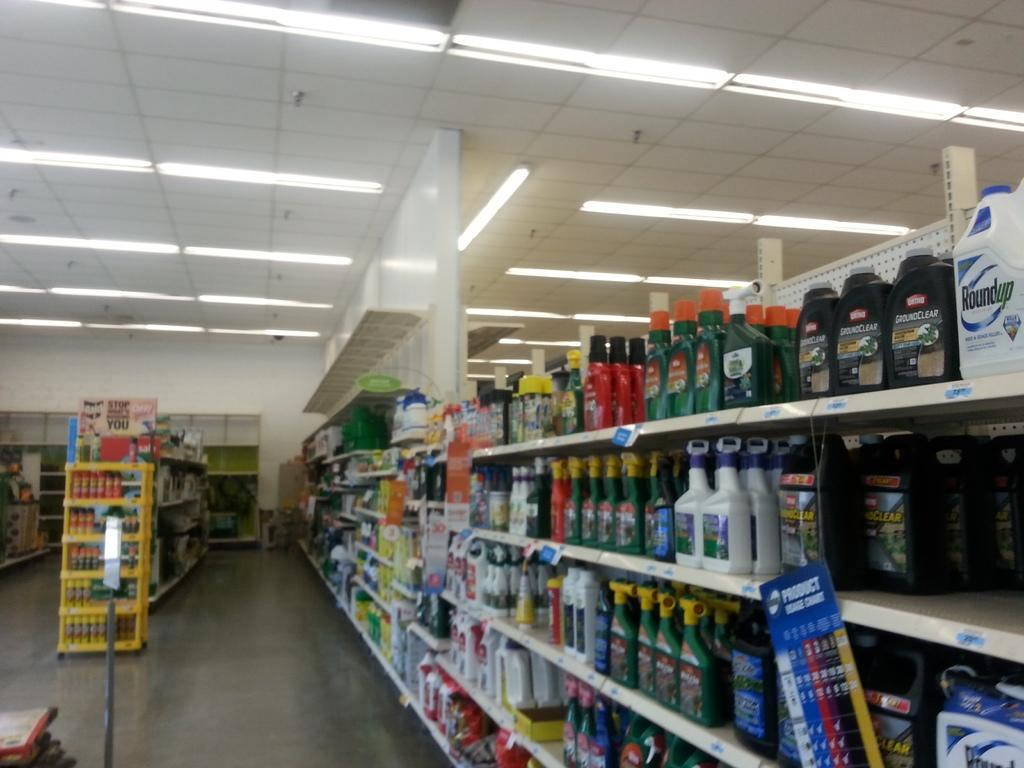<image>
Give a short and clear explanation of the subsequent image. A product usage chart hangs off a shelf. 